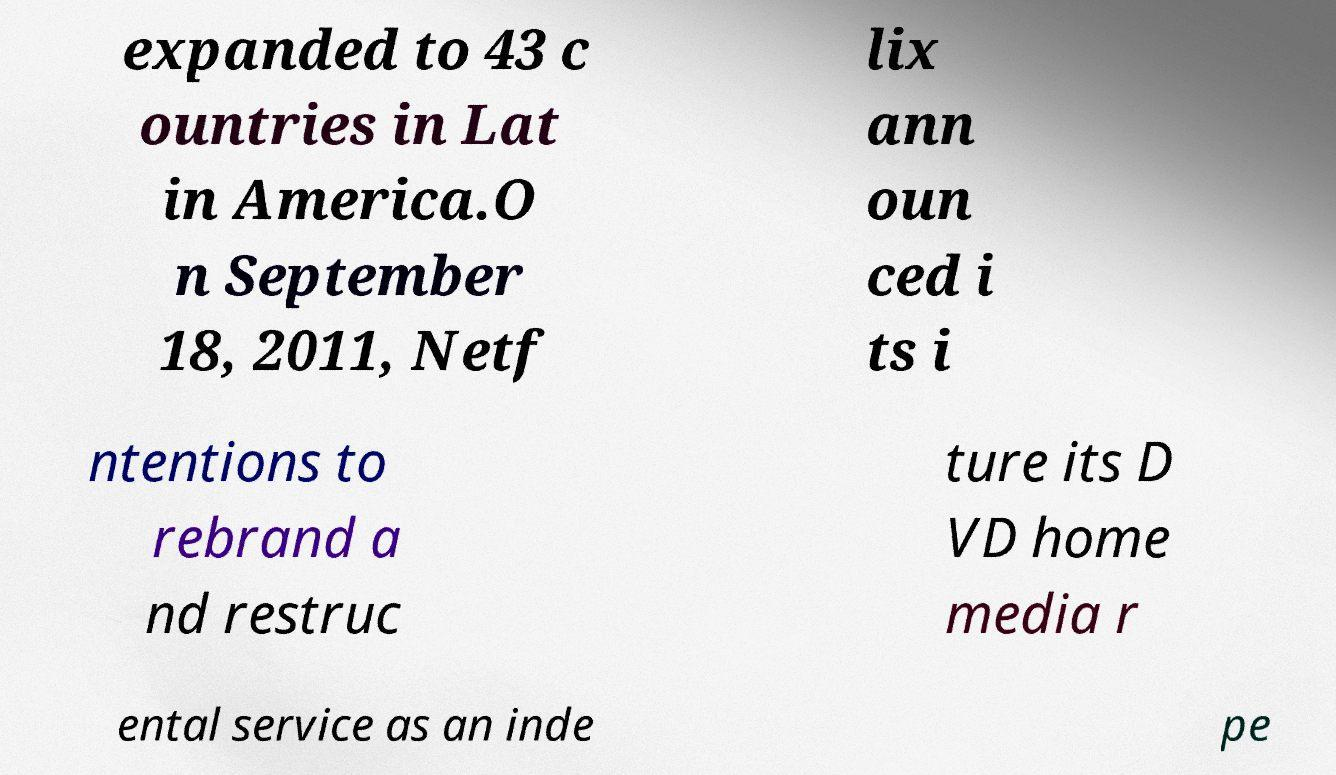Please identify and transcribe the text found in this image. expanded to 43 c ountries in Lat in America.O n September 18, 2011, Netf lix ann oun ced i ts i ntentions to rebrand a nd restruc ture its D VD home media r ental service as an inde pe 